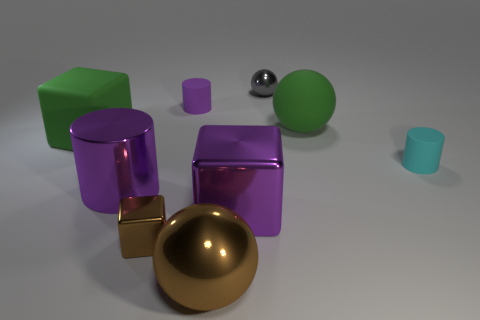Do the large rubber object that is on the left side of the big purple cylinder and the metallic cube to the left of the large brown ball have the same color?
Provide a succinct answer. No. Are there any cubes made of the same material as the big purple cylinder?
Give a very brief answer. Yes. How many red things are big metallic cylinders or spheres?
Ensure brevity in your answer.  0. Are there more purple things that are right of the big purple metal cylinder than small gray shiny spheres?
Make the answer very short. Yes. Does the green cube have the same size as the brown block?
Your response must be concise. No. The sphere that is made of the same material as the small cyan cylinder is what color?
Your answer should be compact. Green. What shape is the large thing that is the same color as the large cylinder?
Provide a short and direct response. Cube. Are there the same number of large purple shiny cubes left of the small purple rubber cylinder and rubber cylinders behind the green ball?
Ensure brevity in your answer.  No. What is the shape of the metallic object that is behind the big green matte object that is right of the small purple object?
Offer a terse response. Sphere. There is another large purple thing that is the same shape as the purple rubber object; what is its material?
Give a very brief answer. Metal. 